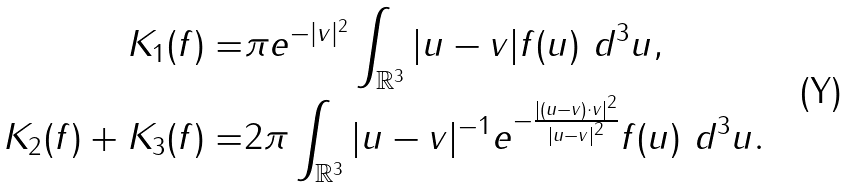<formula> <loc_0><loc_0><loc_500><loc_500>K _ { 1 } ( f ) = & \pi e ^ { - | v | ^ { 2 } } \int _ { \mathbb { R } ^ { 3 } } | u - v | f ( u ) \ d ^ { 3 } u , \\ K _ { 2 } ( f ) + K _ { 3 } ( f ) = & 2 \pi \int _ { \mathbb { R } ^ { 3 } } | u - v | ^ { - 1 } e ^ { - \frac { | ( u - v ) \cdot v | ^ { 2 } } { | u - v | ^ { 2 } } } f ( u ) \ d ^ { 3 } u .</formula> 